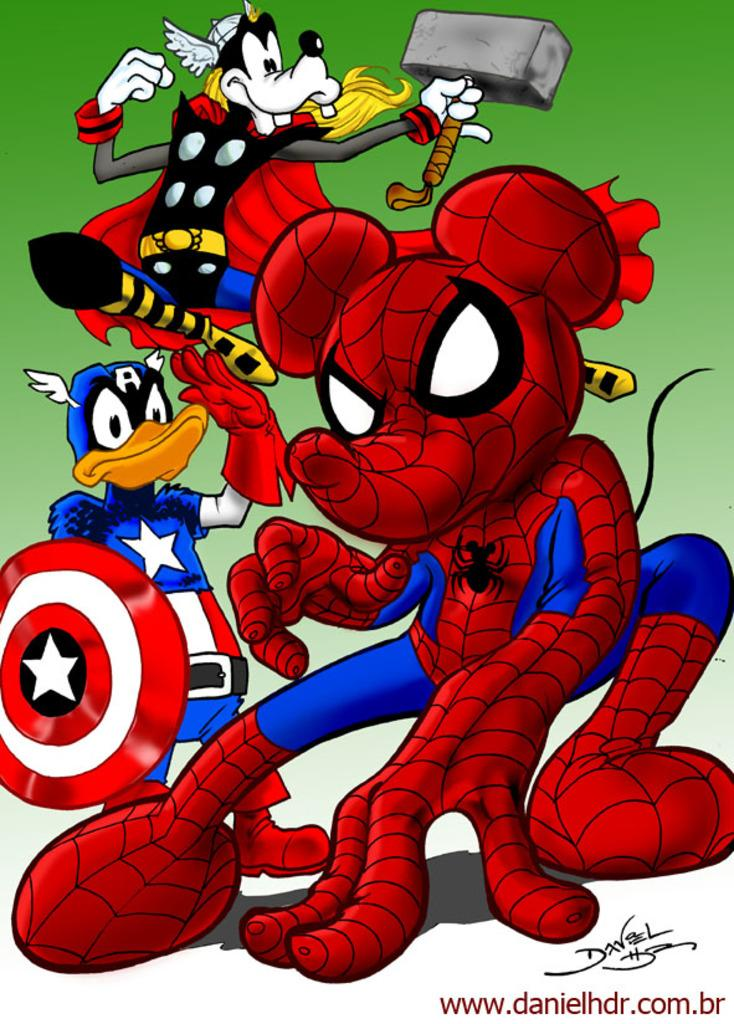What type of image is being described? The image is a cartoon. Which cartoon characters are present in the image? There is a Spider-Man cartoon character and a Mickey Mouse cartoon character in the image. What type of lace can be seen on the face of the Spider-Man cartoon character in the image? There is no lace present on the face of the Spider-Man cartoon character in the image. 